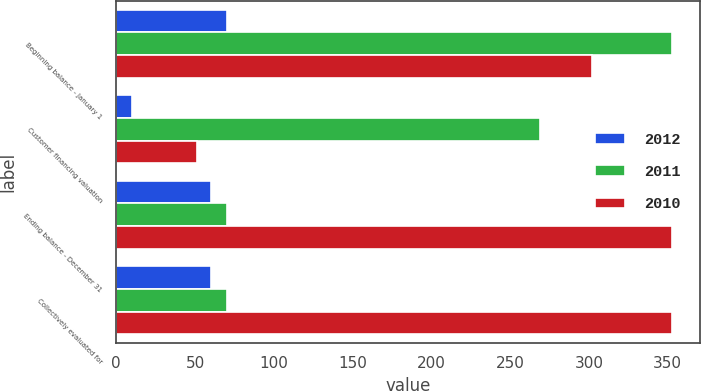Convert chart. <chart><loc_0><loc_0><loc_500><loc_500><stacked_bar_chart><ecel><fcel>Beginning balance - January 1<fcel>Customer financing valuation<fcel>Ending balance - December 31<fcel>Collectively evaluated for<nl><fcel>2012<fcel>70<fcel>10<fcel>60<fcel>60<nl><fcel>2011<fcel>353<fcel>269<fcel>70<fcel>70<nl><fcel>2010<fcel>302<fcel>51<fcel>353<fcel>353<nl></chart> 